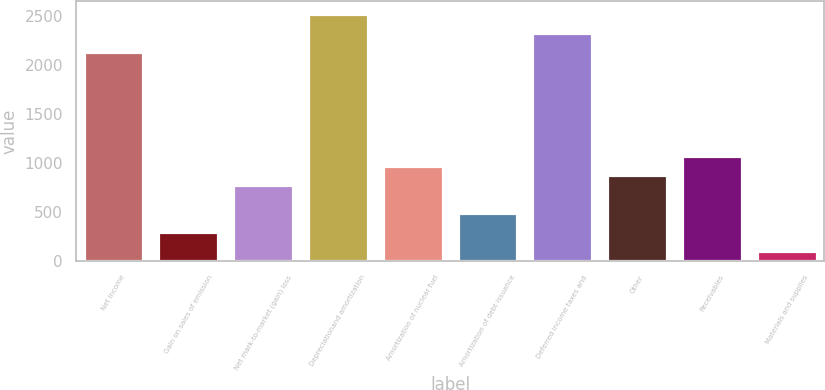<chart> <loc_0><loc_0><loc_500><loc_500><bar_chart><fcel>Net income<fcel>Gain on sales of emission<fcel>Net mark-to-market (gain) loss<fcel>Depreciationand amortization<fcel>Amortization of nuclear fuel<fcel>Amortization of debt issuance<fcel>Deferred income taxes and<fcel>Other<fcel>Receivables<fcel>Materials and supplies<nl><fcel>2137.2<fcel>292.3<fcel>777.8<fcel>2525.6<fcel>972<fcel>486.5<fcel>2331.4<fcel>874.9<fcel>1069.1<fcel>98.1<nl></chart> 